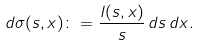<formula> <loc_0><loc_0><loc_500><loc_500>d \sigma ( s , x ) \colon = \frac { l ( s , x ) } { s } \, d s \, d x .</formula> 